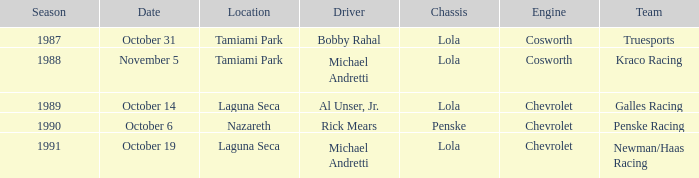Which group competed on october 19? Newman/Haas Racing. 